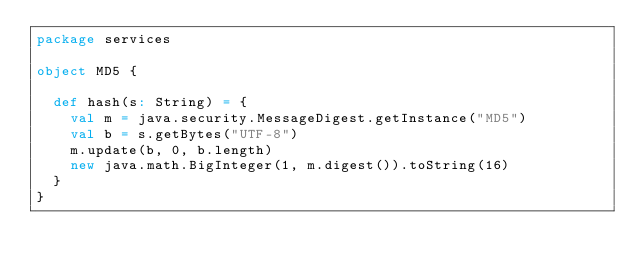Convert code to text. <code><loc_0><loc_0><loc_500><loc_500><_Scala_>package services

object MD5 {

  def hash(s: String) = {
    val m = java.security.MessageDigest.getInstance("MD5")
    val b = s.getBytes("UTF-8")
    m.update(b, 0, b.length)
    new java.math.BigInteger(1, m.digest()).toString(16)
  }
}</code> 